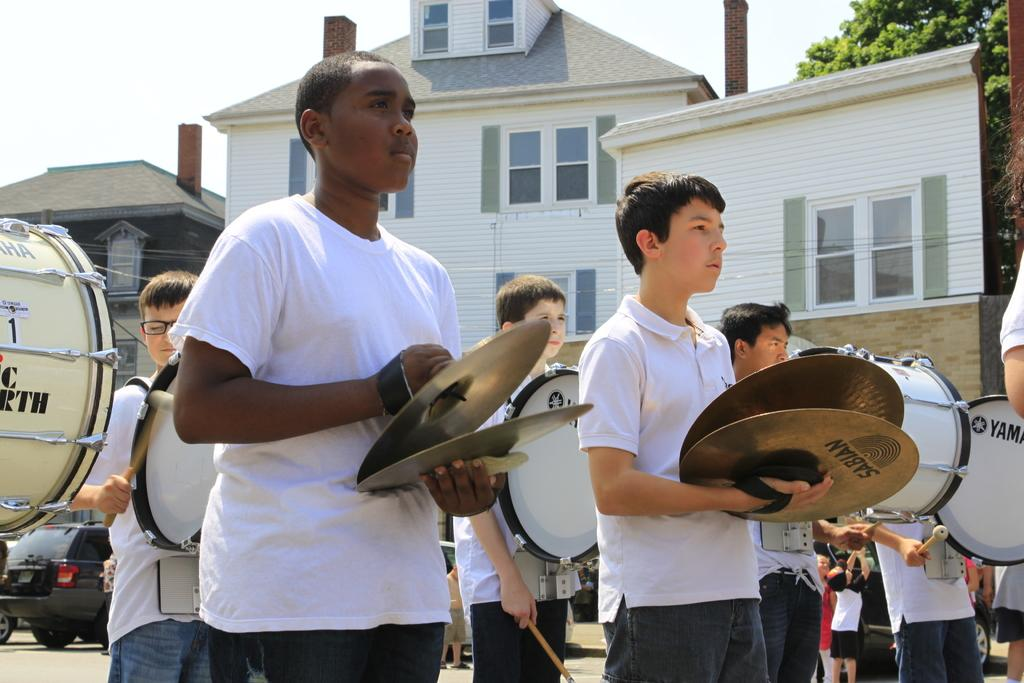<image>
Describe the image concisely. school band member useig instuments by sabian and yamaha 